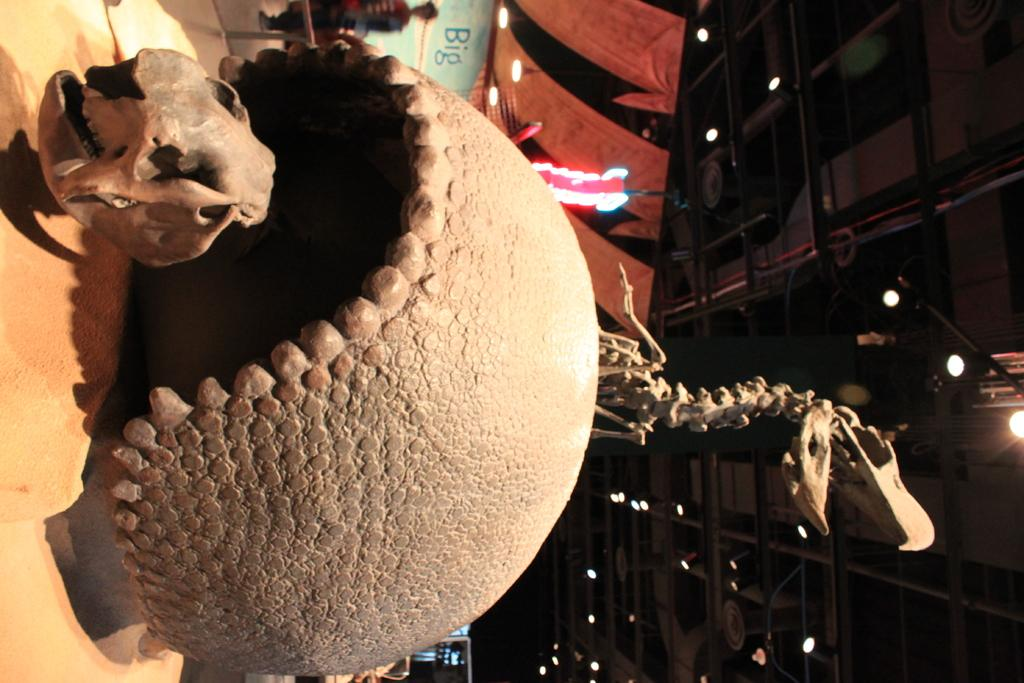What is the main subject of the image? There is a skeleton in the image. Can you describe any other elements in the image besides the skeleton? There are other unspecified things in the image. What can be seen in the background of the image? There are lights, a poster, and people visible in the background of the image. How many goats are visible in the image? There are no goats present in the image. What type of cattle can be seen grazing in the background of the image? There is no cattle visible in the image. 